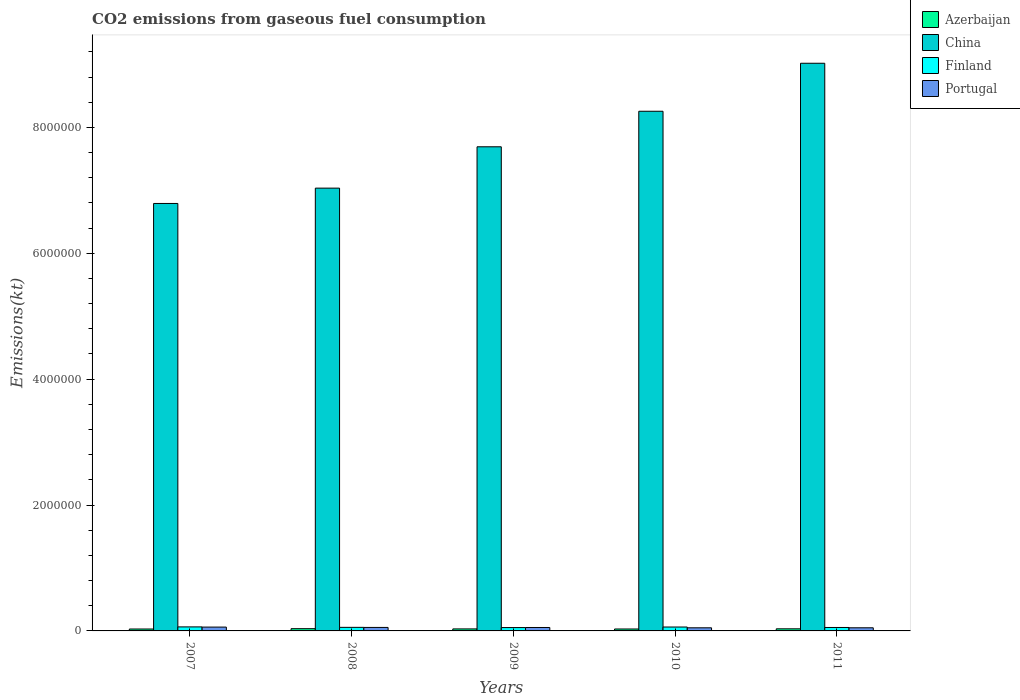Are the number of bars per tick equal to the number of legend labels?
Give a very brief answer. Yes. Are the number of bars on each tick of the X-axis equal?
Ensure brevity in your answer.  Yes. In how many cases, is the number of bars for a given year not equal to the number of legend labels?
Give a very brief answer. 0. What is the amount of CO2 emitted in Finland in 2010?
Provide a short and direct response. 6.18e+04. Across all years, what is the maximum amount of CO2 emitted in Portugal?
Provide a short and direct response. 6.09e+04. Across all years, what is the minimum amount of CO2 emitted in Azerbaijan?
Give a very brief answer. 3.05e+04. In which year was the amount of CO2 emitted in Finland minimum?
Your answer should be compact. 2009. What is the total amount of CO2 emitted in China in the graph?
Provide a succinct answer. 3.88e+07. What is the difference between the amount of CO2 emitted in Finland in 2007 and that in 2008?
Your answer should be compact. 7389. What is the difference between the amount of CO2 emitted in China in 2007 and the amount of CO2 emitted in Azerbaijan in 2008?
Offer a terse response. 6.76e+06. What is the average amount of CO2 emitted in China per year?
Your answer should be compact. 7.76e+06. In the year 2009, what is the difference between the amount of CO2 emitted in Azerbaijan and amount of CO2 emitted in Portugal?
Make the answer very short. -2.26e+04. What is the ratio of the amount of CO2 emitted in Portugal in 2008 to that in 2010?
Ensure brevity in your answer.  1.12. Is the difference between the amount of CO2 emitted in Azerbaijan in 2007 and 2009 greater than the difference between the amount of CO2 emitted in Portugal in 2007 and 2009?
Make the answer very short. No. What is the difference between the highest and the second highest amount of CO2 emitted in Azerbaijan?
Offer a terse response. 2046.19. What is the difference between the highest and the lowest amount of CO2 emitted in Finland?
Offer a terse response. 1.08e+04. In how many years, is the amount of CO2 emitted in Finland greater than the average amount of CO2 emitted in Finland taken over all years?
Keep it short and to the point. 2. Is the sum of the amount of CO2 emitted in Portugal in 2007 and 2011 greater than the maximum amount of CO2 emitted in China across all years?
Provide a short and direct response. No. What does the 1st bar from the left in 2010 represents?
Give a very brief answer. Azerbaijan. What does the 4th bar from the right in 2010 represents?
Provide a succinct answer. Azerbaijan. Is it the case that in every year, the sum of the amount of CO2 emitted in Portugal and amount of CO2 emitted in China is greater than the amount of CO2 emitted in Finland?
Ensure brevity in your answer.  Yes. How many years are there in the graph?
Provide a succinct answer. 5. Are the values on the major ticks of Y-axis written in scientific E-notation?
Give a very brief answer. No. Does the graph contain any zero values?
Your answer should be very brief. No. How many legend labels are there?
Give a very brief answer. 4. How are the legend labels stacked?
Your answer should be compact. Vertical. What is the title of the graph?
Give a very brief answer. CO2 emissions from gaseous fuel consumption. What is the label or title of the X-axis?
Give a very brief answer. Years. What is the label or title of the Y-axis?
Offer a terse response. Emissions(kt). What is the Emissions(kt) of Azerbaijan in 2007?
Provide a short and direct response. 3.05e+04. What is the Emissions(kt) of China in 2007?
Keep it short and to the point. 6.79e+06. What is the Emissions(kt) of Finland in 2007?
Offer a very short reply. 6.40e+04. What is the Emissions(kt) of Portugal in 2007?
Keep it short and to the point. 6.09e+04. What is the Emissions(kt) of Azerbaijan in 2008?
Provide a succinct answer. 3.55e+04. What is the Emissions(kt) in China in 2008?
Your answer should be very brief. 7.04e+06. What is the Emissions(kt) of Finland in 2008?
Your response must be concise. 5.66e+04. What is the Emissions(kt) of Portugal in 2008?
Offer a terse response. 5.54e+04. What is the Emissions(kt) of Azerbaijan in 2009?
Make the answer very short. 3.19e+04. What is the Emissions(kt) in China in 2009?
Offer a very short reply. 7.69e+06. What is the Emissions(kt) in Finland in 2009?
Offer a terse response. 5.32e+04. What is the Emissions(kt) in Portugal in 2009?
Offer a very short reply. 5.45e+04. What is the Emissions(kt) in Azerbaijan in 2010?
Your response must be concise. 3.07e+04. What is the Emissions(kt) in China in 2010?
Offer a very short reply. 8.26e+06. What is the Emissions(kt) in Finland in 2010?
Make the answer very short. 6.18e+04. What is the Emissions(kt) of Portugal in 2010?
Provide a short and direct response. 4.96e+04. What is the Emissions(kt) of Azerbaijan in 2011?
Make the answer very short. 3.35e+04. What is the Emissions(kt) in China in 2011?
Make the answer very short. 9.02e+06. What is the Emissions(kt) of Finland in 2011?
Offer a terse response. 5.48e+04. What is the Emissions(kt) of Portugal in 2011?
Provide a short and direct response. 4.97e+04. Across all years, what is the maximum Emissions(kt) of Azerbaijan?
Make the answer very short. 3.55e+04. Across all years, what is the maximum Emissions(kt) of China?
Offer a very short reply. 9.02e+06. Across all years, what is the maximum Emissions(kt) of Finland?
Offer a terse response. 6.40e+04. Across all years, what is the maximum Emissions(kt) of Portugal?
Offer a very short reply. 6.09e+04. Across all years, what is the minimum Emissions(kt) of Azerbaijan?
Your answer should be compact. 3.05e+04. Across all years, what is the minimum Emissions(kt) of China?
Your answer should be very brief. 6.79e+06. Across all years, what is the minimum Emissions(kt) of Finland?
Offer a very short reply. 5.32e+04. Across all years, what is the minimum Emissions(kt) in Portugal?
Provide a succinct answer. 4.96e+04. What is the total Emissions(kt) in Azerbaijan in the graph?
Your response must be concise. 1.62e+05. What is the total Emissions(kt) in China in the graph?
Provide a short and direct response. 3.88e+07. What is the total Emissions(kt) in Finland in the graph?
Give a very brief answer. 2.90e+05. What is the total Emissions(kt) of Portugal in the graph?
Your response must be concise. 2.70e+05. What is the difference between the Emissions(kt) of Azerbaijan in 2007 and that in 2008?
Offer a terse response. -4994.45. What is the difference between the Emissions(kt) in China in 2007 and that in 2008?
Offer a very short reply. -2.44e+05. What is the difference between the Emissions(kt) in Finland in 2007 and that in 2008?
Offer a very short reply. 7389.01. What is the difference between the Emissions(kt) in Portugal in 2007 and that in 2008?
Your response must be concise. 5500.5. What is the difference between the Emissions(kt) in Azerbaijan in 2007 and that in 2009?
Offer a very short reply. -1393.46. What is the difference between the Emissions(kt) in China in 2007 and that in 2009?
Provide a succinct answer. -9.00e+05. What is the difference between the Emissions(kt) in Finland in 2007 and that in 2009?
Offer a very short reply. 1.08e+04. What is the difference between the Emissions(kt) of Portugal in 2007 and that in 2009?
Offer a terse response. 6347.58. What is the difference between the Emissions(kt) of Azerbaijan in 2007 and that in 2010?
Provide a succinct answer. -168.68. What is the difference between the Emissions(kt) of China in 2007 and that in 2010?
Provide a short and direct response. -1.47e+06. What is the difference between the Emissions(kt) of Finland in 2007 and that in 2010?
Give a very brief answer. 2141.53. What is the difference between the Emissions(kt) in Portugal in 2007 and that in 2010?
Offer a terse response. 1.13e+04. What is the difference between the Emissions(kt) of Azerbaijan in 2007 and that in 2011?
Provide a succinct answer. -2948.27. What is the difference between the Emissions(kt) of China in 2007 and that in 2011?
Your answer should be compact. -2.23e+06. What is the difference between the Emissions(kt) in Finland in 2007 and that in 2011?
Offer a very short reply. 9218.84. What is the difference between the Emissions(kt) of Portugal in 2007 and that in 2011?
Your answer should be compact. 1.11e+04. What is the difference between the Emissions(kt) of Azerbaijan in 2008 and that in 2009?
Ensure brevity in your answer.  3600.99. What is the difference between the Emissions(kt) of China in 2008 and that in 2009?
Offer a terse response. -6.57e+05. What is the difference between the Emissions(kt) in Finland in 2008 and that in 2009?
Ensure brevity in your answer.  3428.64. What is the difference between the Emissions(kt) in Portugal in 2008 and that in 2009?
Provide a succinct answer. 847.08. What is the difference between the Emissions(kt) of Azerbaijan in 2008 and that in 2010?
Your answer should be compact. 4825.77. What is the difference between the Emissions(kt) in China in 2008 and that in 2010?
Your response must be concise. -1.22e+06. What is the difference between the Emissions(kt) of Finland in 2008 and that in 2010?
Offer a very short reply. -5247.48. What is the difference between the Emissions(kt) of Portugal in 2008 and that in 2010?
Give a very brief answer. 5775.52. What is the difference between the Emissions(kt) in Azerbaijan in 2008 and that in 2011?
Make the answer very short. 2046.19. What is the difference between the Emissions(kt) of China in 2008 and that in 2011?
Provide a short and direct response. -1.98e+06. What is the difference between the Emissions(kt) of Finland in 2008 and that in 2011?
Keep it short and to the point. 1829.83. What is the difference between the Emissions(kt) in Portugal in 2008 and that in 2011?
Give a very brief answer. 5639.85. What is the difference between the Emissions(kt) of Azerbaijan in 2009 and that in 2010?
Provide a short and direct response. 1224.78. What is the difference between the Emissions(kt) of China in 2009 and that in 2010?
Provide a short and direct response. -5.65e+05. What is the difference between the Emissions(kt) of Finland in 2009 and that in 2010?
Offer a terse response. -8676.12. What is the difference between the Emissions(kt) in Portugal in 2009 and that in 2010?
Keep it short and to the point. 4928.45. What is the difference between the Emissions(kt) in Azerbaijan in 2009 and that in 2011?
Keep it short and to the point. -1554.81. What is the difference between the Emissions(kt) of China in 2009 and that in 2011?
Make the answer very short. -1.33e+06. What is the difference between the Emissions(kt) of Finland in 2009 and that in 2011?
Your response must be concise. -1598.81. What is the difference between the Emissions(kt) in Portugal in 2009 and that in 2011?
Offer a very short reply. 4792.77. What is the difference between the Emissions(kt) in Azerbaijan in 2010 and that in 2011?
Ensure brevity in your answer.  -2779.59. What is the difference between the Emissions(kt) of China in 2010 and that in 2011?
Ensure brevity in your answer.  -7.63e+05. What is the difference between the Emissions(kt) in Finland in 2010 and that in 2011?
Offer a terse response. 7077.31. What is the difference between the Emissions(kt) of Portugal in 2010 and that in 2011?
Keep it short and to the point. -135.68. What is the difference between the Emissions(kt) in Azerbaijan in 2007 and the Emissions(kt) in China in 2008?
Your answer should be compact. -7.00e+06. What is the difference between the Emissions(kt) of Azerbaijan in 2007 and the Emissions(kt) of Finland in 2008?
Ensure brevity in your answer.  -2.61e+04. What is the difference between the Emissions(kt) of Azerbaijan in 2007 and the Emissions(kt) of Portugal in 2008?
Provide a succinct answer. -2.49e+04. What is the difference between the Emissions(kt) of China in 2007 and the Emissions(kt) of Finland in 2008?
Ensure brevity in your answer.  6.74e+06. What is the difference between the Emissions(kt) of China in 2007 and the Emissions(kt) of Portugal in 2008?
Give a very brief answer. 6.74e+06. What is the difference between the Emissions(kt) in Finland in 2007 and the Emissions(kt) in Portugal in 2008?
Give a very brief answer. 8621.12. What is the difference between the Emissions(kt) in Azerbaijan in 2007 and the Emissions(kt) in China in 2009?
Offer a very short reply. -7.66e+06. What is the difference between the Emissions(kt) in Azerbaijan in 2007 and the Emissions(kt) in Finland in 2009?
Provide a succinct answer. -2.27e+04. What is the difference between the Emissions(kt) of Azerbaijan in 2007 and the Emissions(kt) of Portugal in 2009?
Offer a very short reply. -2.40e+04. What is the difference between the Emissions(kt) of China in 2007 and the Emissions(kt) of Finland in 2009?
Offer a very short reply. 6.74e+06. What is the difference between the Emissions(kt) of China in 2007 and the Emissions(kt) of Portugal in 2009?
Ensure brevity in your answer.  6.74e+06. What is the difference between the Emissions(kt) in Finland in 2007 and the Emissions(kt) in Portugal in 2009?
Your answer should be compact. 9468.19. What is the difference between the Emissions(kt) in Azerbaijan in 2007 and the Emissions(kt) in China in 2010?
Ensure brevity in your answer.  -8.23e+06. What is the difference between the Emissions(kt) of Azerbaijan in 2007 and the Emissions(kt) of Finland in 2010?
Your answer should be very brief. -3.13e+04. What is the difference between the Emissions(kt) of Azerbaijan in 2007 and the Emissions(kt) of Portugal in 2010?
Offer a very short reply. -1.91e+04. What is the difference between the Emissions(kt) of China in 2007 and the Emissions(kt) of Finland in 2010?
Offer a terse response. 6.73e+06. What is the difference between the Emissions(kt) in China in 2007 and the Emissions(kt) in Portugal in 2010?
Your answer should be very brief. 6.74e+06. What is the difference between the Emissions(kt) in Finland in 2007 and the Emissions(kt) in Portugal in 2010?
Ensure brevity in your answer.  1.44e+04. What is the difference between the Emissions(kt) in Azerbaijan in 2007 and the Emissions(kt) in China in 2011?
Offer a terse response. -8.99e+06. What is the difference between the Emissions(kt) in Azerbaijan in 2007 and the Emissions(kt) in Finland in 2011?
Offer a terse response. -2.43e+04. What is the difference between the Emissions(kt) of Azerbaijan in 2007 and the Emissions(kt) of Portugal in 2011?
Make the answer very short. -1.92e+04. What is the difference between the Emissions(kt) of China in 2007 and the Emissions(kt) of Finland in 2011?
Give a very brief answer. 6.74e+06. What is the difference between the Emissions(kt) of China in 2007 and the Emissions(kt) of Portugal in 2011?
Provide a succinct answer. 6.74e+06. What is the difference between the Emissions(kt) in Finland in 2007 and the Emissions(kt) in Portugal in 2011?
Keep it short and to the point. 1.43e+04. What is the difference between the Emissions(kt) in Azerbaijan in 2008 and the Emissions(kt) in China in 2009?
Offer a very short reply. -7.66e+06. What is the difference between the Emissions(kt) of Azerbaijan in 2008 and the Emissions(kt) of Finland in 2009?
Your answer should be compact. -1.77e+04. What is the difference between the Emissions(kt) of Azerbaijan in 2008 and the Emissions(kt) of Portugal in 2009?
Give a very brief answer. -1.90e+04. What is the difference between the Emissions(kt) in China in 2008 and the Emissions(kt) in Finland in 2009?
Give a very brief answer. 6.98e+06. What is the difference between the Emissions(kt) in China in 2008 and the Emissions(kt) in Portugal in 2009?
Your response must be concise. 6.98e+06. What is the difference between the Emissions(kt) in Finland in 2008 and the Emissions(kt) in Portugal in 2009?
Offer a terse response. 2079.19. What is the difference between the Emissions(kt) of Azerbaijan in 2008 and the Emissions(kt) of China in 2010?
Make the answer very short. -8.22e+06. What is the difference between the Emissions(kt) of Azerbaijan in 2008 and the Emissions(kt) of Finland in 2010?
Your answer should be compact. -2.63e+04. What is the difference between the Emissions(kt) in Azerbaijan in 2008 and the Emissions(kt) in Portugal in 2010?
Your answer should be compact. -1.41e+04. What is the difference between the Emissions(kt) in China in 2008 and the Emissions(kt) in Finland in 2010?
Keep it short and to the point. 6.97e+06. What is the difference between the Emissions(kt) in China in 2008 and the Emissions(kt) in Portugal in 2010?
Your response must be concise. 6.99e+06. What is the difference between the Emissions(kt) in Finland in 2008 and the Emissions(kt) in Portugal in 2010?
Offer a terse response. 7007.64. What is the difference between the Emissions(kt) in Azerbaijan in 2008 and the Emissions(kt) in China in 2011?
Keep it short and to the point. -8.98e+06. What is the difference between the Emissions(kt) in Azerbaijan in 2008 and the Emissions(kt) in Finland in 2011?
Offer a very short reply. -1.93e+04. What is the difference between the Emissions(kt) of Azerbaijan in 2008 and the Emissions(kt) of Portugal in 2011?
Make the answer very short. -1.42e+04. What is the difference between the Emissions(kt) of China in 2008 and the Emissions(kt) of Finland in 2011?
Offer a terse response. 6.98e+06. What is the difference between the Emissions(kt) in China in 2008 and the Emissions(kt) in Portugal in 2011?
Make the answer very short. 6.99e+06. What is the difference between the Emissions(kt) of Finland in 2008 and the Emissions(kt) of Portugal in 2011?
Offer a very short reply. 6871.96. What is the difference between the Emissions(kt) in Azerbaijan in 2009 and the Emissions(kt) in China in 2010?
Make the answer very short. -8.23e+06. What is the difference between the Emissions(kt) in Azerbaijan in 2009 and the Emissions(kt) in Finland in 2010?
Ensure brevity in your answer.  -2.99e+04. What is the difference between the Emissions(kt) in Azerbaijan in 2009 and the Emissions(kt) in Portugal in 2010?
Make the answer very short. -1.77e+04. What is the difference between the Emissions(kt) of China in 2009 and the Emissions(kt) of Finland in 2010?
Keep it short and to the point. 7.63e+06. What is the difference between the Emissions(kt) of China in 2009 and the Emissions(kt) of Portugal in 2010?
Offer a terse response. 7.64e+06. What is the difference between the Emissions(kt) of Finland in 2009 and the Emissions(kt) of Portugal in 2010?
Provide a short and direct response. 3578.99. What is the difference between the Emissions(kt) in Azerbaijan in 2009 and the Emissions(kt) in China in 2011?
Give a very brief answer. -8.99e+06. What is the difference between the Emissions(kt) in Azerbaijan in 2009 and the Emissions(kt) in Finland in 2011?
Your answer should be compact. -2.29e+04. What is the difference between the Emissions(kt) in Azerbaijan in 2009 and the Emissions(kt) in Portugal in 2011?
Your answer should be very brief. -1.78e+04. What is the difference between the Emissions(kt) in China in 2009 and the Emissions(kt) in Finland in 2011?
Provide a short and direct response. 7.64e+06. What is the difference between the Emissions(kt) in China in 2009 and the Emissions(kt) in Portugal in 2011?
Make the answer very short. 7.64e+06. What is the difference between the Emissions(kt) in Finland in 2009 and the Emissions(kt) in Portugal in 2011?
Keep it short and to the point. 3443.31. What is the difference between the Emissions(kt) of Azerbaijan in 2010 and the Emissions(kt) of China in 2011?
Your answer should be very brief. -8.99e+06. What is the difference between the Emissions(kt) of Azerbaijan in 2010 and the Emissions(kt) of Finland in 2011?
Your answer should be very brief. -2.41e+04. What is the difference between the Emissions(kt) of Azerbaijan in 2010 and the Emissions(kt) of Portugal in 2011?
Offer a terse response. -1.90e+04. What is the difference between the Emissions(kt) in China in 2010 and the Emissions(kt) in Finland in 2011?
Ensure brevity in your answer.  8.20e+06. What is the difference between the Emissions(kt) of China in 2010 and the Emissions(kt) of Portugal in 2011?
Give a very brief answer. 8.21e+06. What is the difference between the Emissions(kt) of Finland in 2010 and the Emissions(kt) of Portugal in 2011?
Your answer should be very brief. 1.21e+04. What is the average Emissions(kt) in Azerbaijan per year?
Keep it short and to the point. 3.24e+04. What is the average Emissions(kt) in China per year?
Ensure brevity in your answer.  7.76e+06. What is the average Emissions(kt) of Finland per year?
Provide a succinct answer. 5.81e+04. What is the average Emissions(kt) of Portugal per year?
Keep it short and to the point. 5.40e+04. In the year 2007, what is the difference between the Emissions(kt) of Azerbaijan and Emissions(kt) of China?
Make the answer very short. -6.76e+06. In the year 2007, what is the difference between the Emissions(kt) of Azerbaijan and Emissions(kt) of Finland?
Ensure brevity in your answer.  -3.35e+04. In the year 2007, what is the difference between the Emissions(kt) in Azerbaijan and Emissions(kt) in Portugal?
Your response must be concise. -3.04e+04. In the year 2007, what is the difference between the Emissions(kt) in China and Emissions(kt) in Finland?
Your answer should be very brief. 6.73e+06. In the year 2007, what is the difference between the Emissions(kt) of China and Emissions(kt) of Portugal?
Keep it short and to the point. 6.73e+06. In the year 2007, what is the difference between the Emissions(kt) in Finland and Emissions(kt) in Portugal?
Make the answer very short. 3120.62. In the year 2008, what is the difference between the Emissions(kt) of Azerbaijan and Emissions(kt) of China?
Provide a short and direct response. -7.00e+06. In the year 2008, what is the difference between the Emissions(kt) in Azerbaijan and Emissions(kt) in Finland?
Make the answer very short. -2.11e+04. In the year 2008, what is the difference between the Emissions(kt) in Azerbaijan and Emissions(kt) in Portugal?
Ensure brevity in your answer.  -1.99e+04. In the year 2008, what is the difference between the Emissions(kt) in China and Emissions(kt) in Finland?
Offer a terse response. 6.98e+06. In the year 2008, what is the difference between the Emissions(kt) in China and Emissions(kt) in Portugal?
Your response must be concise. 6.98e+06. In the year 2008, what is the difference between the Emissions(kt) of Finland and Emissions(kt) of Portugal?
Offer a very short reply. 1232.11. In the year 2009, what is the difference between the Emissions(kt) in Azerbaijan and Emissions(kt) in China?
Provide a succinct answer. -7.66e+06. In the year 2009, what is the difference between the Emissions(kt) in Azerbaijan and Emissions(kt) in Finland?
Ensure brevity in your answer.  -2.13e+04. In the year 2009, what is the difference between the Emissions(kt) of Azerbaijan and Emissions(kt) of Portugal?
Keep it short and to the point. -2.26e+04. In the year 2009, what is the difference between the Emissions(kt) of China and Emissions(kt) of Finland?
Your answer should be very brief. 7.64e+06. In the year 2009, what is the difference between the Emissions(kt) in China and Emissions(kt) in Portugal?
Ensure brevity in your answer.  7.64e+06. In the year 2009, what is the difference between the Emissions(kt) in Finland and Emissions(kt) in Portugal?
Make the answer very short. -1349.46. In the year 2010, what is the difference between the Emissions(kt) of Azerbaijan and Emissions(kt) of China?
Offer a very short reply. -8.23e+06. In the year 2010, what is the difference between the Emissions(kt) in Azerbaijan and Emissions(kt) in Finland?
Provide a short and direct response. -3.12e+04. In the year 2010, what is the difference between the Emissions(kt) of Azerbaijan and Emissions(kt) of Portugal?
Make the answer very short. -1.89e+04. In the year 2010, what is the difference between the Emissions(kt) in China and Emissions(kt) in Finland?
Keep it short and to the point. 8.20e+06. In the year 2010, what is the difference between the Emissions(kt) in China and Emissions(kt) in Portugal?
Provide a short and direct response. 8.21e+06. In the year 2010, what is the difference between the Emissions(kt) in Finland and Emissions(kt) in Portugal?
Offer a terse response. 1.23e+04. In the year 2011, what is the difference between the Emissions(kt) of Azerbaijan and Emissions(kt) of China?
Offer a terse response. -8.99e+06. In the year 2011, what is the difference between the Emissions(kt) in Azerbaijan and Emissions(kt) in Finland?
Give a very brief answer. -2.13e+04. In the year 2011, what is the difference between the Emissions(kt) of Azerbaijan and Emissions(kt) of Portugal?
Your answer should be very brief. -1.63e+04. In the year 2011, what is the difference between the Emissions(kt) in China and Emissions(kt) in Finland?
Offer a terse response. 8.96e+06. In the year 2011, what is the difference between the Emissions(kt) in China and Emissions(kt) in Portugal?
Your answer should be compact. 8.97e+06. In the year 2011, what is the difference between the Emissions(kt) of Finland and Emissions(kt) of Portugal?
Offer a very short reply. 5042.12. What is the ratio of the Emissions(kt) in Azerbaijan in 2007 to that in 2008?
Your answer should be very brief. 0.86. What is the ratio of the Emissions(kt) of China in 2007 to that in 2008?
Keep it short and to the point. 0.97. What is the ratio of the Emissions(kt) of Finland in 2007 to that in 2008?
Your response must be concise. 1.13. What is the ratio of the Emissions(kt) in Portugal in 2007 to that in 2008?
Provide a succinct answer. 1.1. What is the ratio of the Emissions(kt) in Azerbaijan in 2007 to that in 2009?
Offer a very short reply. 0.96. What is the ratio of the Emissions(kt) in China in 2007 to that in 2009?
Provide a short and direct response. 0.88. What is the ratio of the Emissions(kt) of Finland in 2007 to that in 2009?
Provide a short and direct response. 1.2. What is the ratio of the Emissions(kt) of Portugal in 2007 to that in 2009?
Provide a succinct answer. 1.12. What is the ratio of the Emissions(kt) in China in 2007 to that in 2010?
Your answer should be very brief. 0.82. What is the ratio of the Emissions(kt) of Finland in 2007 to that in 2010?
Provide a succinct answer. 1.03. What is the ratio of the Emissions(kt) in Portugal in 2007 to that in 2010?
Ensure brevity in your answer.  1.23. What is the ratio of the Emissions(kt) of Azerbaijan in 2007 to that in 2011?
Give a very brief answer. 0.91. What is the ratio of the Emissions(kt) in China in 2007 to that in 2011?
Give a very brief answer. 0.75. What is the ratio of the Emissions(kt) of Finland in 2007 to that in 2011?
Your answer should be compact. 1.17. What is the ratio of the Emissions(kt) in Portugal in 2007 to that in 2011?
Provide a succinct answer. 1.22. What is the ratio of the Emissions(kt) in Azerbaijan in 2008 to that in 2009?
Provide a succinct answer. 1.11. What is the ratio of the Emissions(kt) of China in 2008 to that in 2009?
Keep it short and to the point. 0.91. What is the ratio of the Emissions(kt) of Finland in 2008 to that in 2009?
Your answer should be compact. 1.06. What is the ratio of the Emissions(kt) in Portugal in 2008 to that in 2009?
Provide a succinct answer. 1.02. What is the ratio of the Emissions(kt) of Azerbaijan in 2008 to that in 2010?
Provide a succinct answer. 1.16. What is the ratio of the Emissions(kt) in China in 2008 to that in 2010?
Your answer should be compact. 0.85. What is the ratio of the Emissions(kt) in Finland in 2008 to that in 2010?
Provide a succinct answer. 0.92. What is the ratio of the Emissions(kt) of Portugal in 2008 to that in 2010?
Your answer should be very brief. 1.12. What is the ratio of the Emissions(kt) of Azerbaijan in 2008 to that in 2011?
Make the answer very short. 1.06. What is the ratio of the Emissions(kt) in China in 2008 to that in 2011?
Keep it short and to the point. 0.78. What is the ratio of the Emissions(kt) in Finland in 2008 to that in 2011?
Provide a short and direct response. 1.03. What is the ratio of the Emissions(kt) in Portugal in 2008 to that in 2011?
Give a very brief answer. 1.11. What is the ratio of the Emissions(kt) in Azerbaijan in 2009 to that in 2010?
Keep it short and to the point. 1.04. What is the ratio of the Emissions(kt) of China in 2009 to that in 2010?
Your response must be concise. 0.93. What is the ratio of the Emissions(kt) of Finland in 2009 to that in 2010?
Provide a succinct answer. 0.86. What is the ratio of the Emissions(kt) in Portugal in 2009 to that in 2010?
Ensure brevity in your answer.  1.1. What is the ratio of the Emissions(kt) in Azerbaijan in 2009 to that in 2011?
Your answer should be compact. 0.95. What is the ratio of the Emissions(kt) in China in 2009 to that in 2011?
Offer a very short reply. 0.85. What is the ratio of the Emissions(kt) in Finland in 2009 to that in 2011?
Give a very brief answer. 0.97. What is the ratio of the Emissions(kt) in Portugal in 2009 to that in 2011?
Make the answer very short. 1.1. What is the ratio of the Emissions(kt) of Azerbaijan in 2010 to that in 2011?
Your answer should be very brief. 0.92. What is the ratio of the Emissions(kt) in China in 2010 to that in 2011?
Offer a terse response. 0.92. What is the ratio of the Emissions(kt) in Finland in 2010 to that in 2011?
Your answer should be compact. 1.13. What is the ratio of the Emissions(kt) of Portugal in 2010 to that in 2011?
Provide a short and direct response. 1. What is the difference between the highest and the second highest Emissions(kt) in Azerbaijan?
Your response must be concise. 2046.19. What is the difference between the highest and the second highest Emissions(kt) in China?
Offer a terse response. 7.63e+05. What is the difference between the highest and the second highest Emissions(kt) of Finland?
Give a very brief answer. 2141.53. What is the difference between the highest and the second highest Emissions(kt) in Portugal?
Give a very brief answer. 5500.5. What is the difference between the highest and the lowest Emissions(kt) of Azerbaijan?
Provide a succinct answer. 4994.45. What is the difference between the highest and the lowest Emissions(kt) in China?
Provide a succinct answer. 2.23e+06. What is the difference between the highest and the lowest Emissions(kt) of Finland?
Provide a short and direct response. 1.08e+04. What is the difference between the highest and the lowest Emissions(kt) in Portugal?
Offer a terse response. 1.13e+04. 